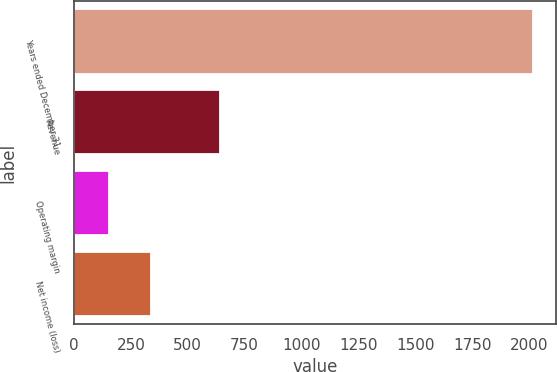Convert chart. <chart><loc_0><loc_0><loc_500><loc_500><bar_chart><fcel>Years ended December 31<fcel>Revenue<fcel>Operating margin<fcel>Net income (loss)<nl><fcel>2015<fcel>641<fcel>152<fcel>338.3<nl></chart> 